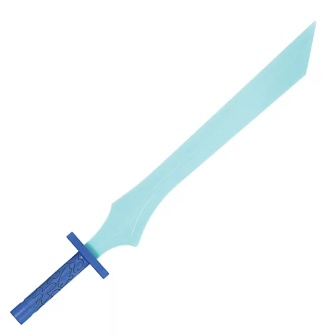This toy sword looks like it belongs in a fantastic world. Can you describe such a world where this sword might be used? Imagine a fantastical world named Astralheim, where magic and mythical creatures are a part of everyday life. This vibrant realm is filled with enchanted forests, towering castles, and crystal-clear waters. In Astralheim, courageous knights wield swords like this one, which are imbued with magical powers. The sword's light blue blade emits a soft glow, capable of cutting through the toughest enchantments. The floral design on the pommel symbolizes the guardianship of nature, granting its bearer the strength to protect the realm's sacred groves from dark sorcery and formidable beasts. 